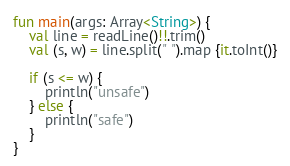Convert code to text. <code><loc_0><loc_0><loc_500><loc_500><_Kotlin_>fun main(args: Array<String>) {
    val line = readLine()!!.trim()
    val (s, w) = line.split(" ").map {it.toInt()}

    if (s <= w) {
        println("unsafe")
    } else {
        println("safe")
    }
}</code> 